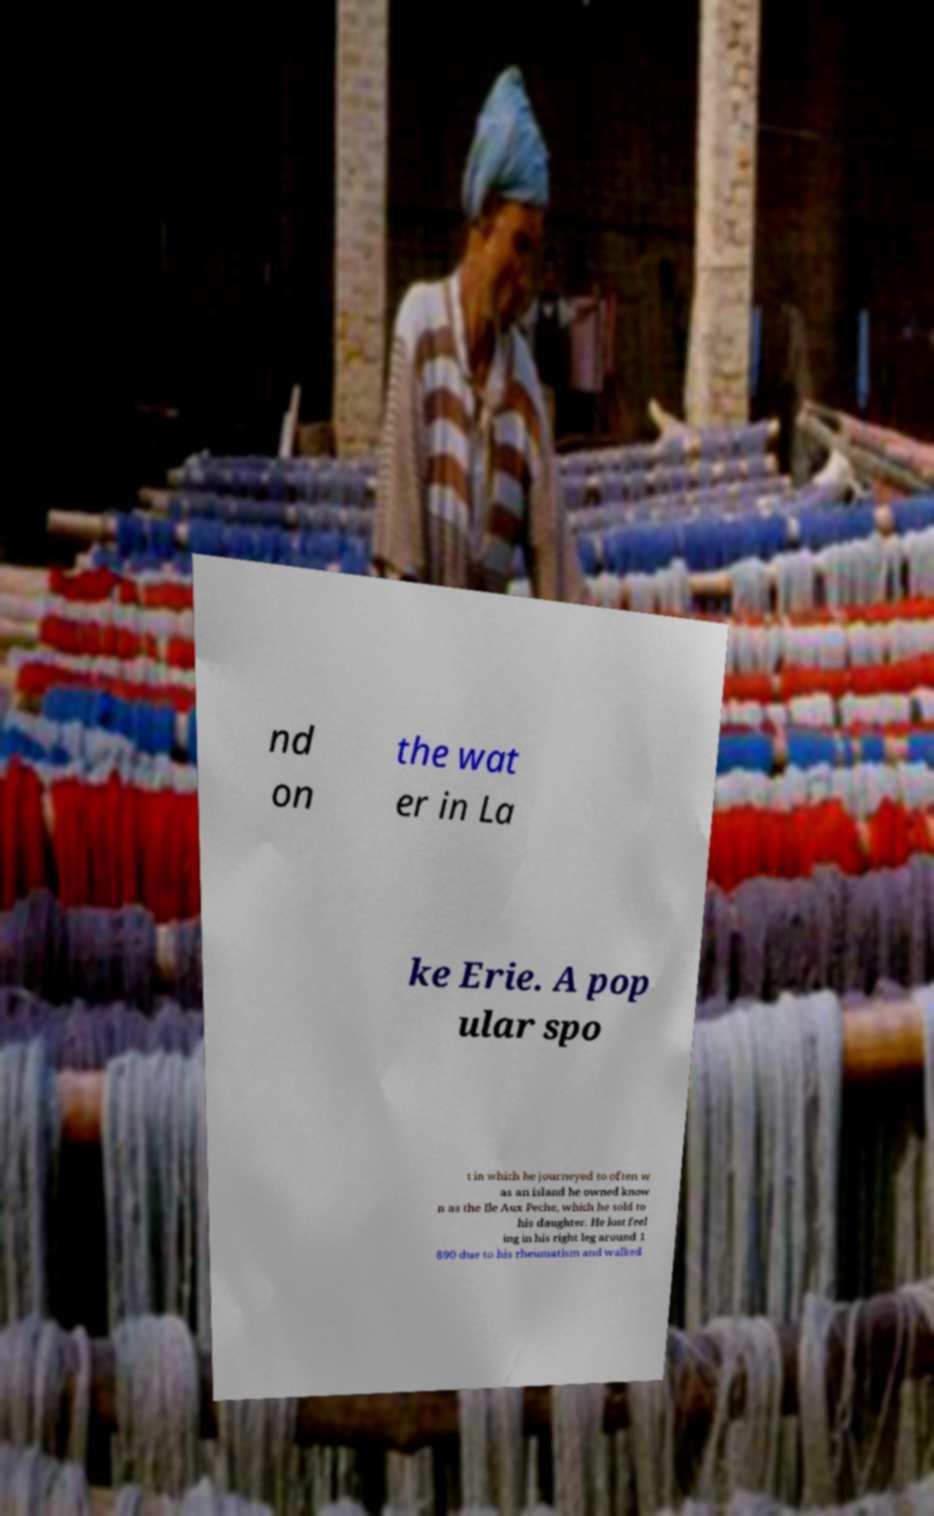Could you assist in decoding the text presented in this image and type it out clearly? nd on the wat er in La ke Erie. A pop ular spo t in which he journeyed to often w as an island he owned know n as the Ile Aux Peche, which he sold to his daughter. He lost feel ing in his right leg around 1 890 due to his rheumatism and walked 